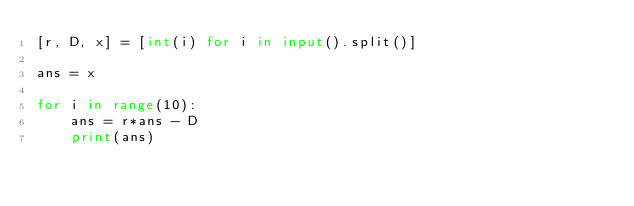Convert code to text. <code><loc_0><loc_0><loc_500><loc_500><_Python_>[r, D, x] = [int(i) for i in input().split()]

ans = x

for i in range(10):
    ans = r*ans - D
    print(ans)
    </code> 